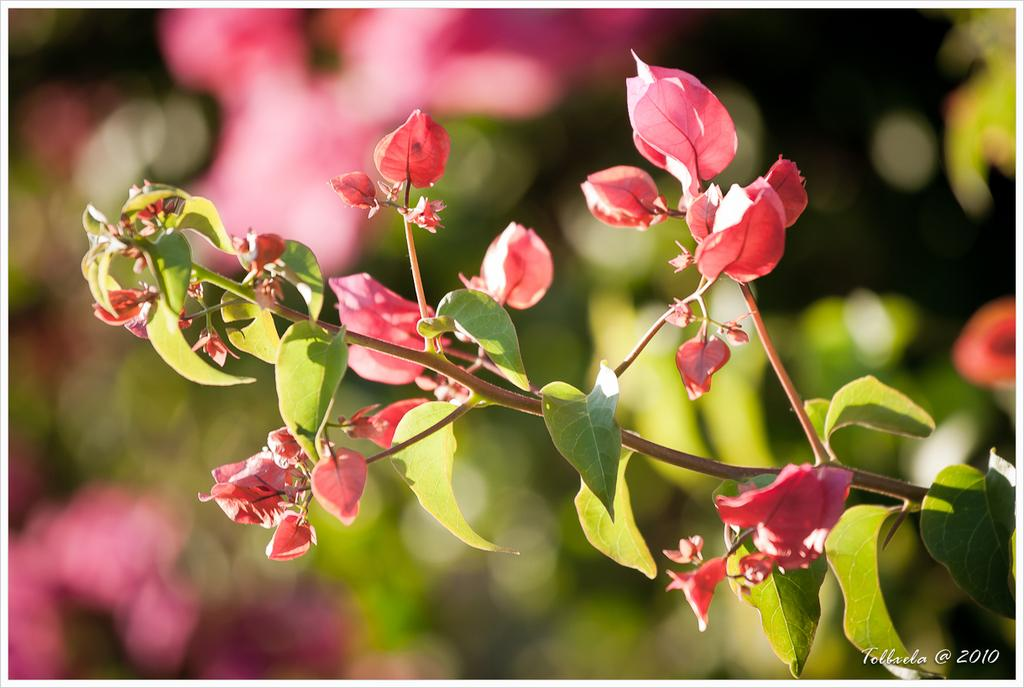What is located in the middle of the image? There are plants, flowers, leaves, and stems in the middle of the image. Can you describe the components of the plants in the image? The plants in the image have flowers, leaves, and stems. What is written or depicted at the bottom of the image? There is text at the bottom of the image. What can be seen in the background of the image? There are plants in the background of the image. What type of beam is holding up the roof in the image? There is no roof or beam present in the image; it features plants, flowers, leaves, and stems in the middle, with text at the bottom and plants in the background. 